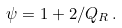Convert formula to latex. <formula><loc_0><loc_0><loc_500><loc_500>\psi = 1 + 2 / Q _ { R } \, .</formula> 